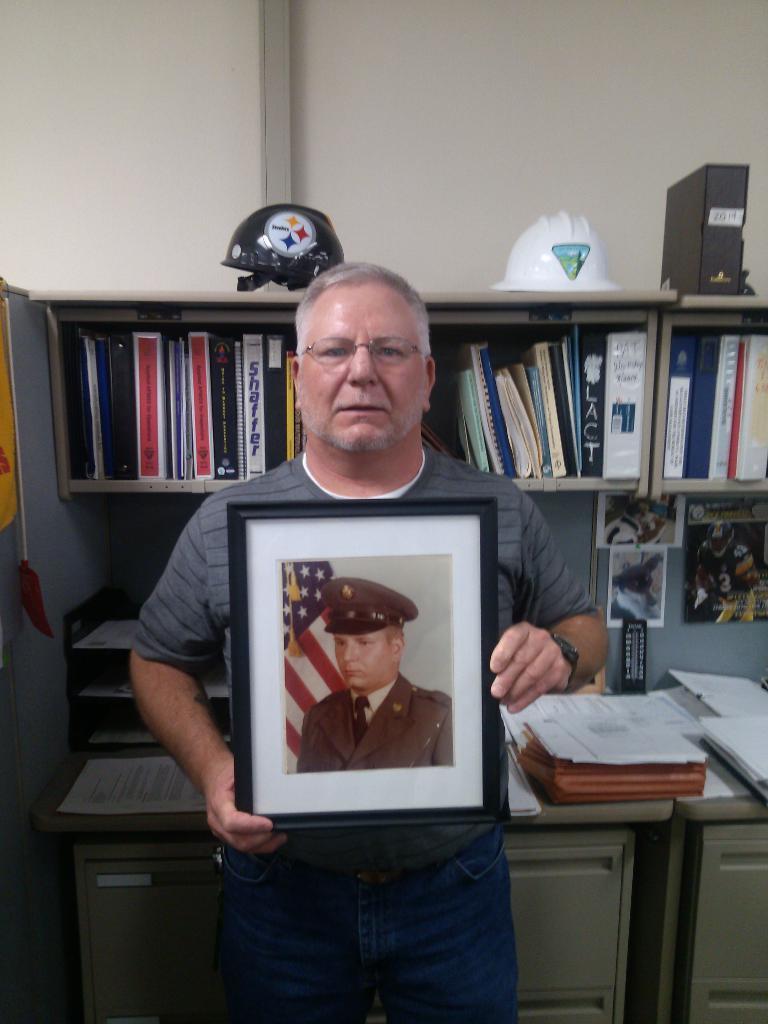In one or two sentences, can you explain what this image depicts? In this picture we can see a man who is holding a frame with his hands. He has spectacles. On the background we can see a rack and there are some books. And this is wall. 